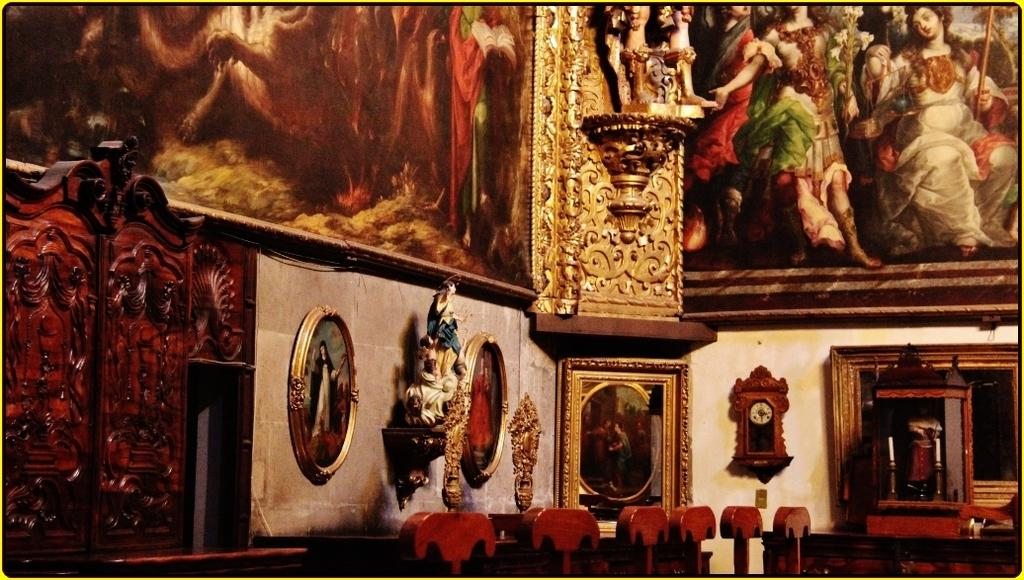What is depicted on the wall in the image? There are paintings on the wall in the image. What type of sculptures can be seen in the image? There are sculptures with wooden frames in the image. Can you describe the material of the sculptures? The sculptures are made of wood. How is the wrench being used in the distribution of the paintings in the image? There is no wrench present in the image, and therefore no such activity can be observed. 